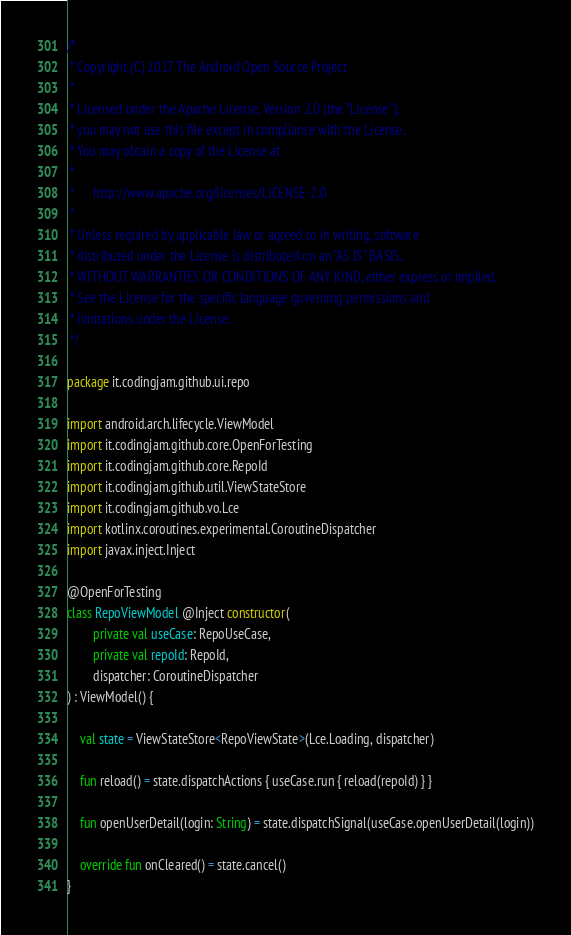<code> <loc_0><loc_0><loc_500><loc_500><_Kotlin_>/*
 * Copyright (C) 2017 The Android Open Source Project
 *
 * Licensed under the Apache License, Version 2.0 (the "License");
 * you may not use this file except in compliance with the License.
 * You may obtain a copy of the License at
 *
 *      http://www.apache.org/licenses/LICENSE-2.0
 *
 * Unless required by applicable law or agreed to in writing, software
 * distributed under the License is distributed on an "AS IS" BASIS,
 * WITHOUT WARRANTIES OR CONDITIONS OF ANY KIND, either express or implied.
 * See the License for the specific language governing permissions and
 * limitations under the License.
 */

package it.codingjam.github.ui.repo

import android.arch.lifecycle.ViewModel
import it.codingjam.github.core.OpenForTesting
import it.codingjam.github.core.RepoId
import it.codingjam.github.util.ViewStateStore
import it.codingjam.github.vo.Lce
import kotlinx.coroutines.experimental.CoroutineDispatcher
import javax.inject.Inject

@OpenForTesting
class RepoViewModel @Inject constructor(
        private val useCase: RepoUseCase,
        private val repoId: RepoId,
        dispatcher: CoroutineDispatcher
) : ViewModel() {

    val state = ViewStateStore<RepoViewState>(Lce.Loading, dispatcher)

    fun reload() = state.dispatchActions { useCase.run { reload(repoId) } }

    fun openUserDetail(login: String) = state.dispatchSignal(useCase.openUserDetail(login))

    override fun onCleared() = state.cancel()
}
</code> 